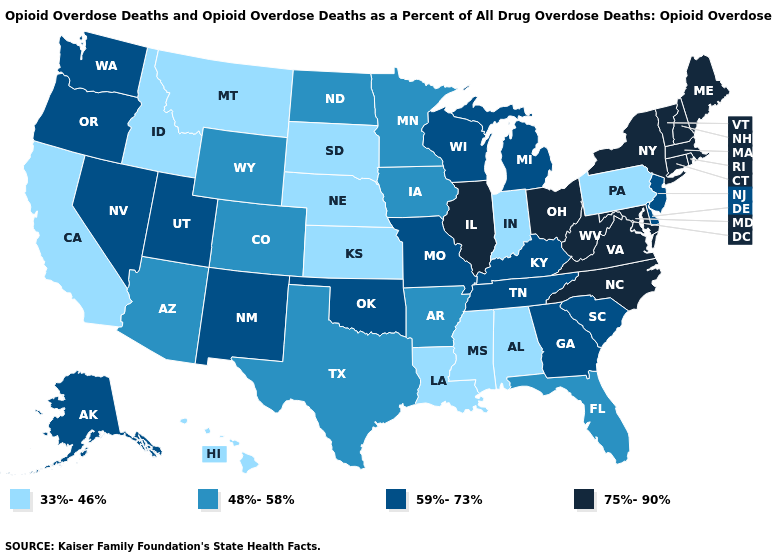Name the states that have a value in the range 48%-58%?
Quick response, please. Arizona, Arkansas, Colorado, Florida, Iowa, Minnesota, North Dakota, Texas, Wyoming. What is the highest value in the West ?
Quick response, please. 59%-73%. What is the value of Indiana?
Short answer required. 33%-46%. Is the legend a continuous bar?
Quick response, please. No. Name the states that have a value in the range 48%-58%?
Write a very short answer. Arizona, Arkansas, Colorado, Florida, Iowa, Minnesota, North Dakota, Texas, Wyoming. How many symbols are there in the legend?
Keep it brief. 4. What is the value of Georgia?
Short answer required. 59%-73%. What is the value of North Carolina?
Write a very short answer. 75%-90%. Does the first symbol in the legend represent the smallest category?
Quick response, please. Yes. Name the states that have a value in the range 33%-46%?
Quick response, please. Alabama, California, Hawaii, Idaho, Indiana, Kansas, Louisiana, Mississippi, Montana, Nebraska, Pennsylvania, South Dakota. Which states have the lowest value in the USA?
Write a very short answer. Alabama, California, Hawaii, Idaho, Indiana, Kansas, Louisiana, Mississippi, Montana, Nebraska, Pennsylvania, South Dakota. Does Rhode Island have the same value as Connecticut?
Be succinct. Yes. Name the states that have a value in the range 33%-46%?
Quick response, please. Alabama, California, Hawaii, Idaho, Indiana, Kansas, Louisiana, Mississippi, Montana, Nebraska, Pennsylvania, South Dakota. Among the states that border Oklahoma , which have the highest value?
Be succinct. Missouri, New Mexico. Name the states that have a value in the range 33%-46%?
Short answer required. Alabama, California, Hawaii, Idaho, Indiana, Kansas, Louisiana, Mississippi, Montana, Nebraska, Pennsylvania, South Dakota. 